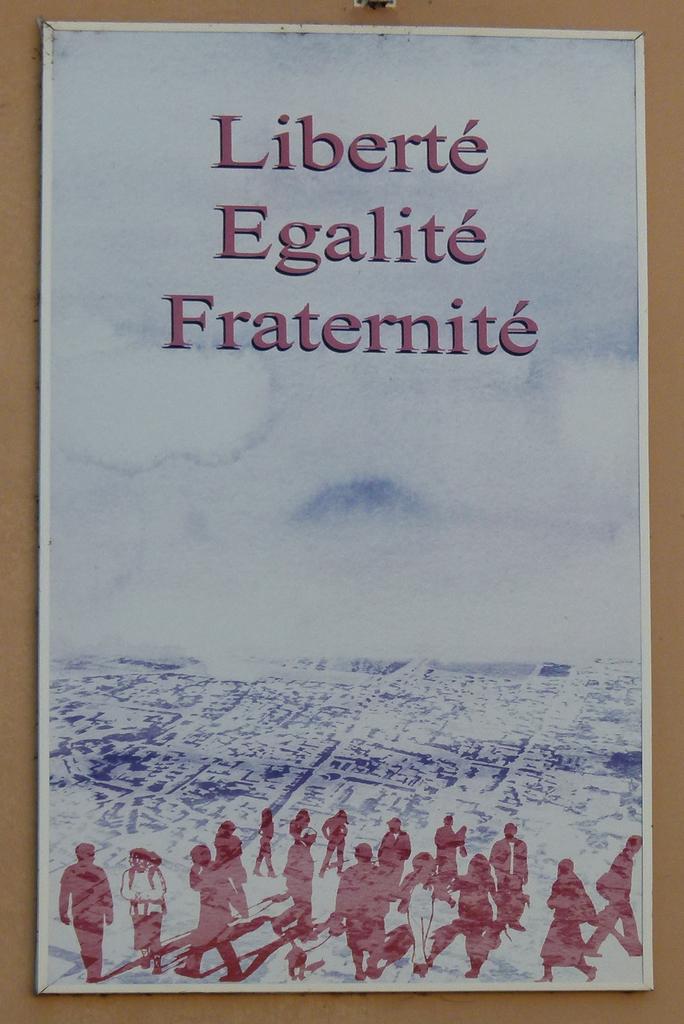What is the motto on this poster?
Your answer should be compact. Liberte egalite fraternite. 